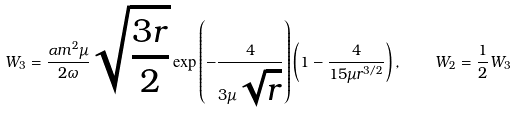Convert formula to latex. <formula><loc_0><loc_0><loc_500><loc_500>W _ { 3 } = \frac { \alpha m ^ { 2 } \mu } { 2 \omega } \sqrt { \frac { 3 r } { 2 } } \exp \left ( - \frac { 4 } { 3 \mu \sqrt { r } } \right ) \left ( 1 - \frac { 4 } { 1 5 \mu r ^ { 3 / 2 } } \right ) , \quad W _ { 2 } = \frac { 1 } { 2 } W _ { 3 }</formula> 